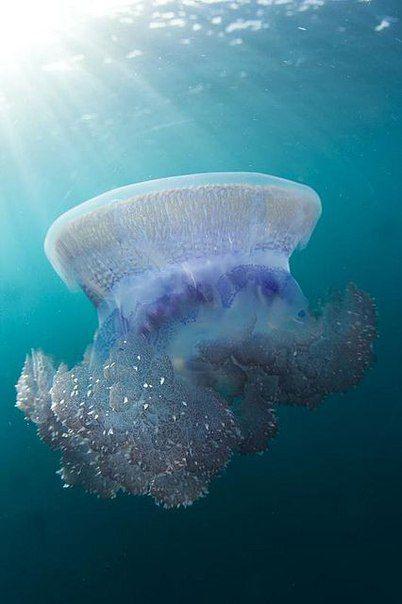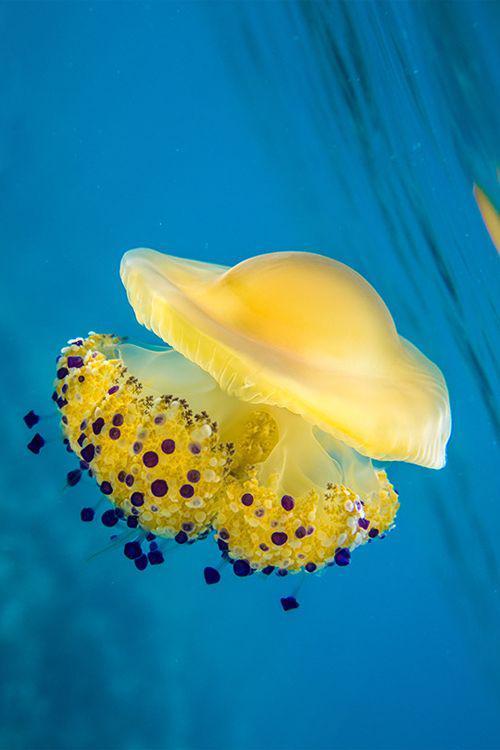The first image is the image on the left, the second image is the image on the right. Evaluate the accuracy of this statement regarding the images: "The jellyfish on the right is yellowish, with a rounded top and a cauliflower-like bottom without long tendrils.". Is it true? Answer yes or no. Yes. 